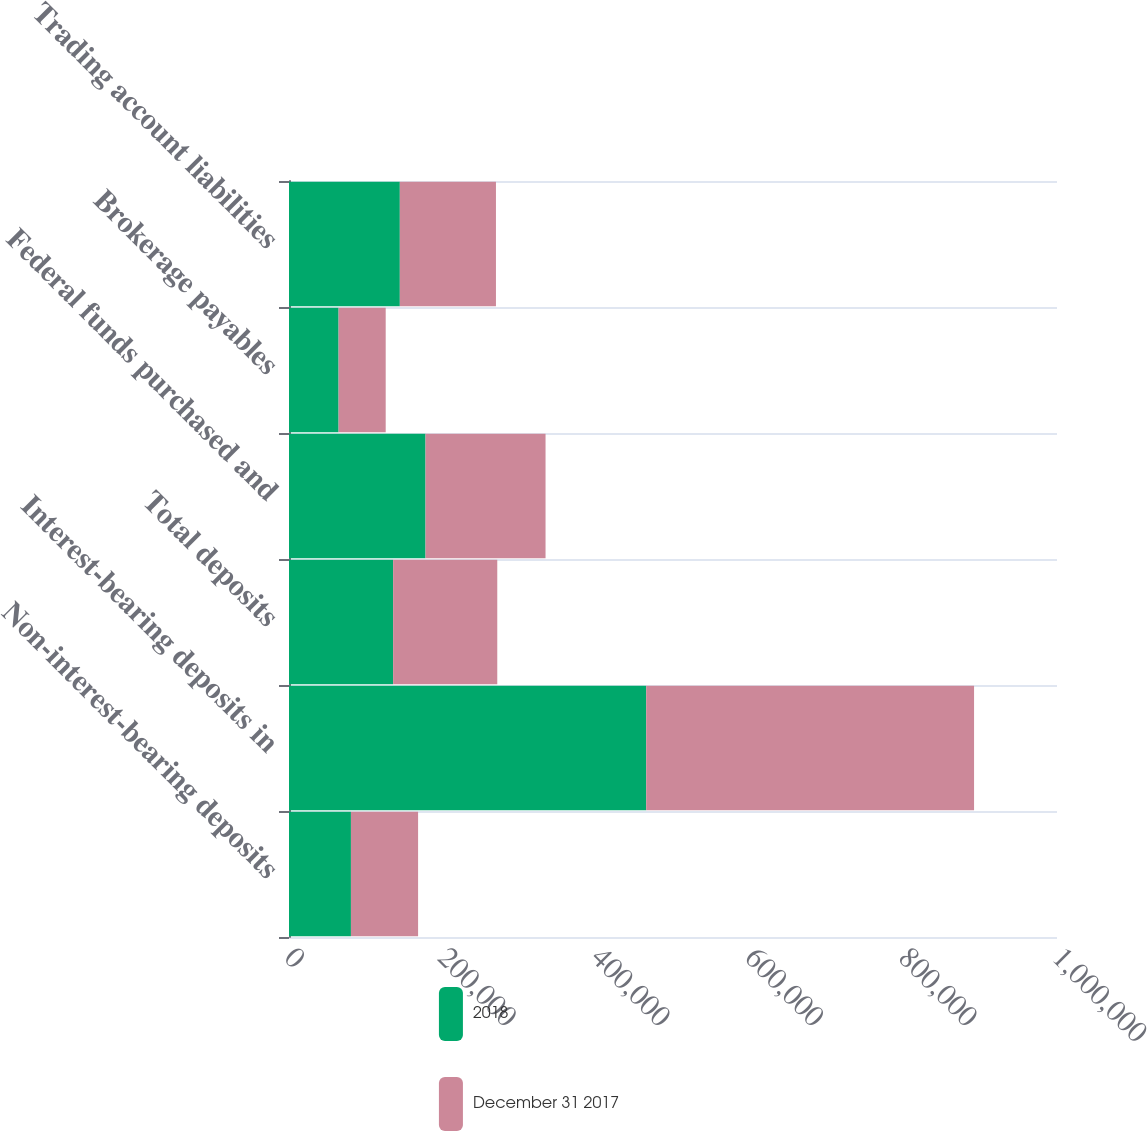Convert chart. <chart><loc_0><loc_0><loc_500><loc_500><stacked_bar_chart><ecel><fcel>Non-interest-bearing deposits<fcel>Interest-bearing deposits in<fcel>Total deposits<fcel>Federal funds purchased and<fcel>Brokerage payables<fcel>Trading account liabilities<nl><fcel>2018<fcel>80648<fcel>465113<fcel>135592<fcel>177768<fcel>64571<fcel>144305<nl><fcel>December 31 2017<fcel>87440<fcel>426889<fcel>135592<fcel>156277<fcel>61342<fcel>125170<nl></chart> 